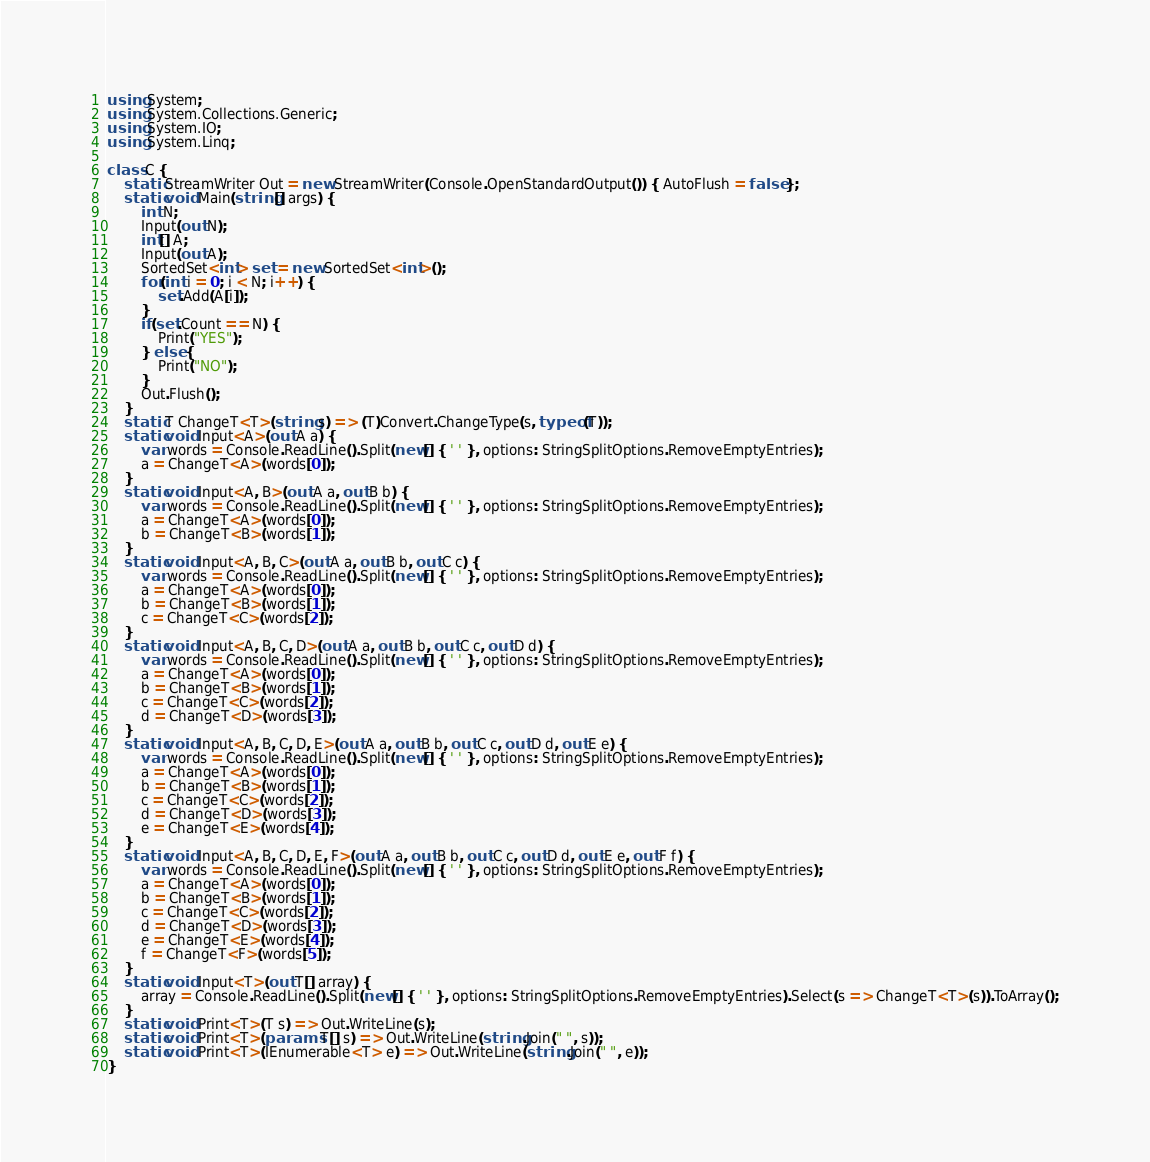<code> <loc_0><loc_0><loc_500><loc_500><_C#_>using System;
using System.Collections.Generic;
using System.IO;
using System.Linq;

class C {
    static StreamWriter Out = new StreamWriter(Console.OpenStandardOutput()) { AutoFlush = false };
    static void Main(string[] args) {
        int N;
        Input(out N);
        int[] A;
        Input(out A);
        SortedSet<int> set = new SortedSet<int>();
        for(int i = 0; i < N; i++) {
            set.Add(A[i]);
        }
        if(set.Count == N) {
            Print("YES");
        } else {
            Print("NO");
        }
        Out.Flush();
    }
    static T ChangeT<T>(string s) => (T)Convert.ChangeType(s, typeof(T));
    static void Input<A>(out A a) {
        var words = Console.ReadLine().Split(new[] { ' ' }, options: StringSplitOptions.RemoveEmptyEntries);
        a = ChangeT<A>(words[0]);
    }
    static void Input<A, B>(out A a, out B b) {
        var words = Console.ReadLine().Split(new[] { ' ' }, options: StringSplitOptions.RemoveEmptyEntries);
        a = ChangeT<A>(words[0]);
        b = ChangeT<B>(words[1]);
    }
    static void Input<A, B, C>(out A a, out B b, out C c) {
        var words = Console.ReadLine().Split(new[] { ' ' }, options: StringSplitOptions.RemoveEmptyEntries);
        a = ChangeT<A>(words[0]);
        b = ChangeT<B>(words[1]);
        c = ChangeT<C>(words[2]);
    }
    static void Input<A, B, C, D>(out A a, out B b, out C c, out D d) {
        var words = Console.ReadLine().Split(new[] { ' ' }, options: StringSplitOptions.RemoveEmptyEntries);
        a = ChangeT<A>(words[0]);
        b = ChangeT<B>(words[1]);
        c = ChangeT<C>(words[2]);
        d = ChangeT<D>(words[3]);
    }
    static void Input<A, B, C, D, E>(out A a, out B b, out C c, out D d, out E e) {
        var words = Console.ReadLine().Split(new[] { ' ' }, options: StringSplitOptions.RemoveEmptyEntries);
        a = ChangeT<A>(words[0]);
        b = ChangeT<B>(words[1]);
        c = ChangeT<C>(words[2]);
        d = ChangeT<D>(words[3]);
        e = ChangeT<E>(words[4]);
    }
    static void Input<A, B, C, D, E, F>(out A a, out B b, out C c, out D d, out E e, out F f) {
        var words = Console.ReadLine().Split(new[] { ' ' }, options: StringSplitOptions.RemoveEmptyEntries);
        a = ChangeT<A>(words[0]);
        b = ChangeT<B>(words[1]);
        c = ChangeT<C>(words[2]);
        d = ChangeT<D>(words[3]);
        e = ChangeT<E>(words[4]);
        f = ChangeT<F>(words[5]);
    }
    static void Input<T>(out T[] array) {
        array = Console.ReadLine().Split(new[] { ' ' }, options: StringSplitOptions.RemoveEmptyEntries).Select(s => ChangeT<T>(s)).ToArray();
    }
    static void Print<T>(T s) => Out.WriteLine(s);
    static void Print<T>(params T[] s) => Out.WriteLine(string.Join(" ", s));
    static void Print<T>(IEnumerable<T> e) => Out.WriteLine(string.Join(" ", e));
}</code> 